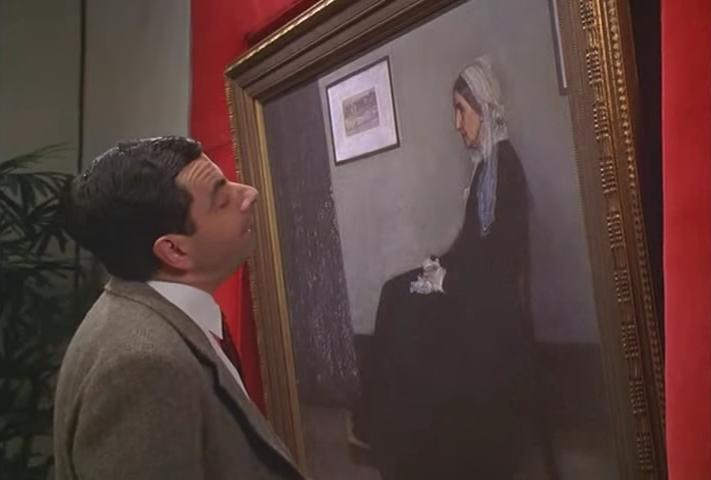Can you describe the main features of this image for me? This image features a character resembling the iconic television figure Mr. Bean, portrayed having a light-hearted interaction with a classical painting. He is dressed in a grey jacket, a white shirt, and a dark tie, standing slightly off-center to the left as he gazes quizzically at the artwork. The painting itself is a somber-toned portrait, set against a red wall, depicting a seated woman in a blue dress wearing a white headscarf, with her hands around a small object—possibly a teapot. The juxtaposition of the character’s typically humorous demeanor with the serious atmosphere of a gallery creates a humorous contrast that is characteristic of the Mr. Bean series. 